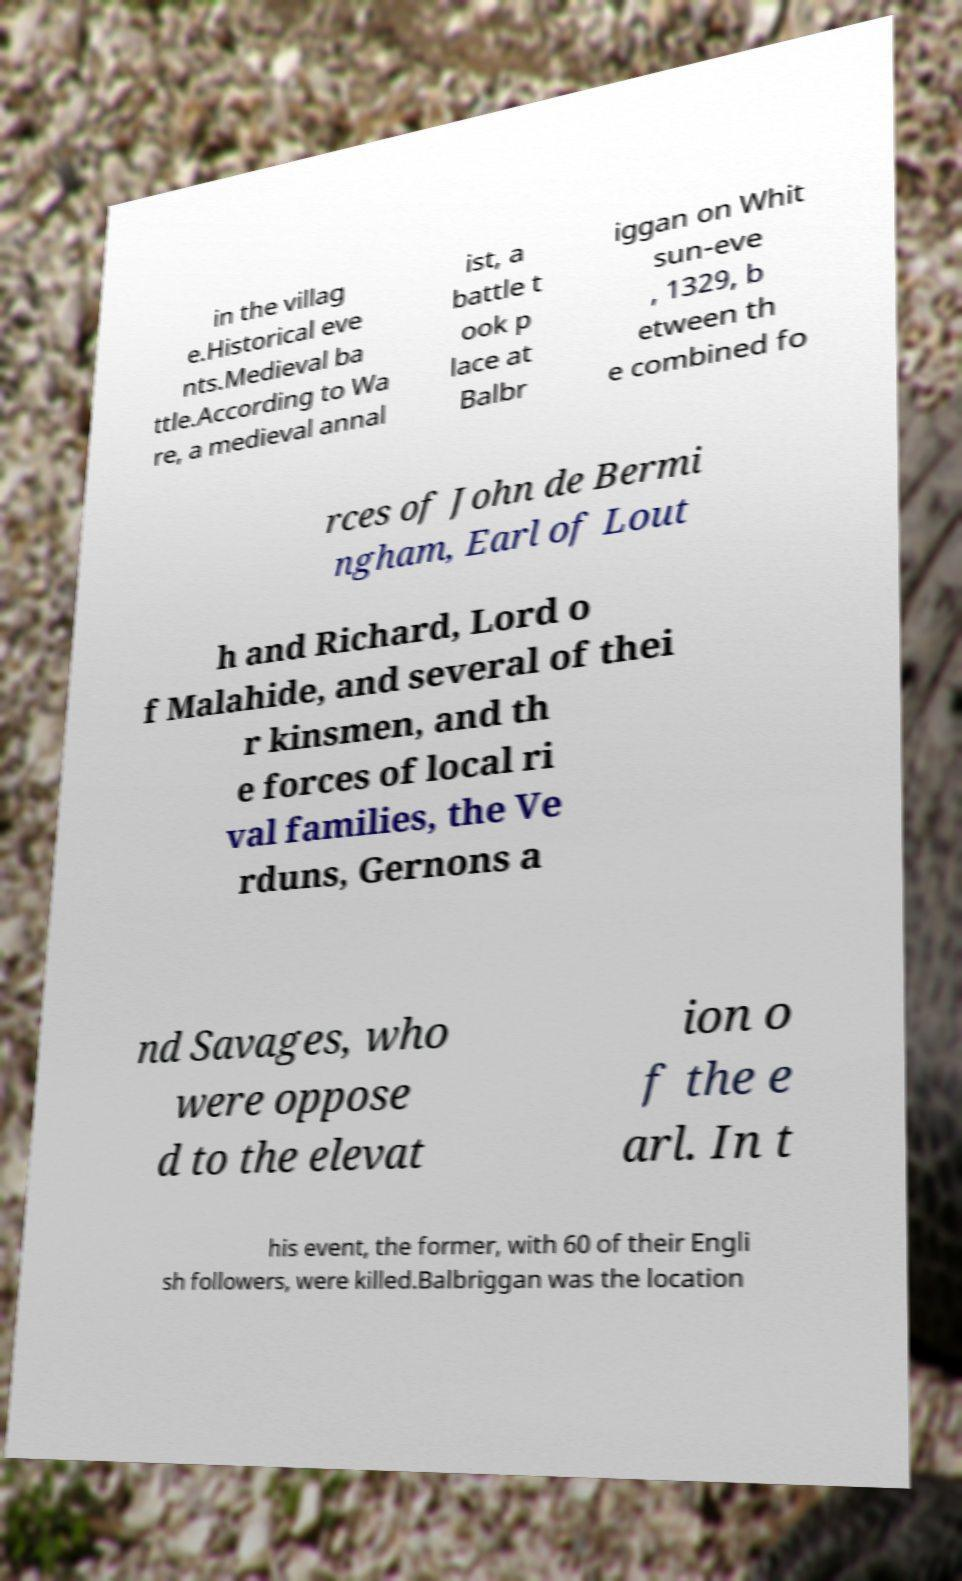There's text embedded in this image that I need extracted. Can you transcribe it verbatim? in the villag e.Historical eve nts.Medieval ba ttle.According to Wa re, a medieval annal ist, a battle t ook p lace at Balbr iggan on Whit sun-eve , 1329, b etween th e combined fo rces of John de Bermi ngham, Earl of Lout h and Richard, Lord o f Malahide, and several of thei r kinsmen, and th e forces of local ri val families, the Ve rduns, Gernons a nd Savages, who were oppose d to the elevat ion o f the e arl. In t his event, the former, with 60 of their Engli sh followers, were killed.Balbriggan was the location 